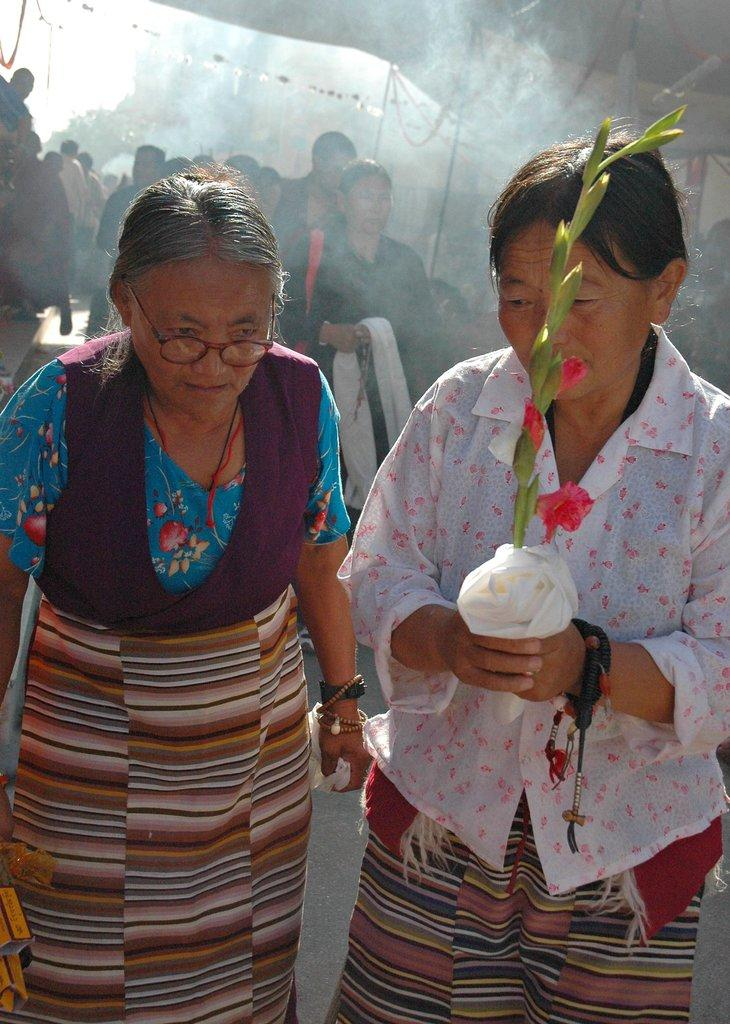How many women are in the foreground of the image? There are two women in the foreground of the image. What is one of the women holding in her hand? One of the women is holding a plant in her hand. What can be seen in the background of the image? There is a crowd, smoke, and a tent visible in the background of the image. What type of grape is being used as a decoration on the locket in the image? There is no grape or locket present in the image. How many calculators can be seen in the hands of the crowd in the background? There is no mention of calculators in the image; the crowd is not described in detail. 